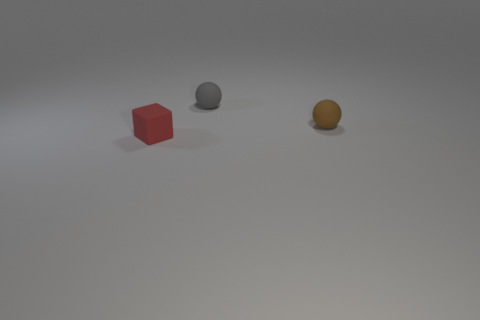Is there any other thing that has the same size as the red block?
Give a very brief answer. Yes. How many objects are tiny red blocks or small objects that are behind the red cube?
Your answer should be very brief. 3. How many other objects are there of the same shape as the small gray matte thing?
Provide a succinct answer. 1. Are there fewer brown matte balls that are in front of the brown matte ball than tiny gray things in front of the matte cube?
Provide a short and direct response. No. Is there any other thing that is made of the same material as the small gray thing?
Make the answer very short. Yes. What is the shape of the small red object that is the same material as the brown object?
Make the answer very short. Cube. Is there anything else that has the same color as the matte cube?
Offer a very short reply. No. There is a tiny rubber object that is behind the small rubber thing to the right of the gray thing; what color is it?
Give a very brief answer. Gray. What material is the thing in front of the rubber ball that is in front of the small rubber object behind the tiny brown rubber thing?
Give a very brief answer. Rubber. What number of gray rubber balls have the same size as the brown sphere?
Provide a short and direct response. 1. 